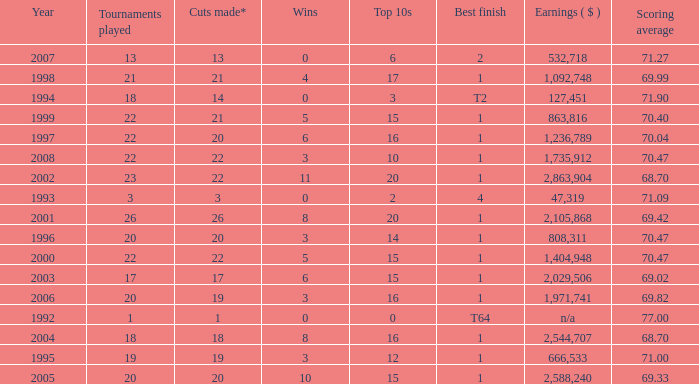Tell me the highest wins for year less than 2000 and best finish of 4 and tournaments played less than 3 None. 